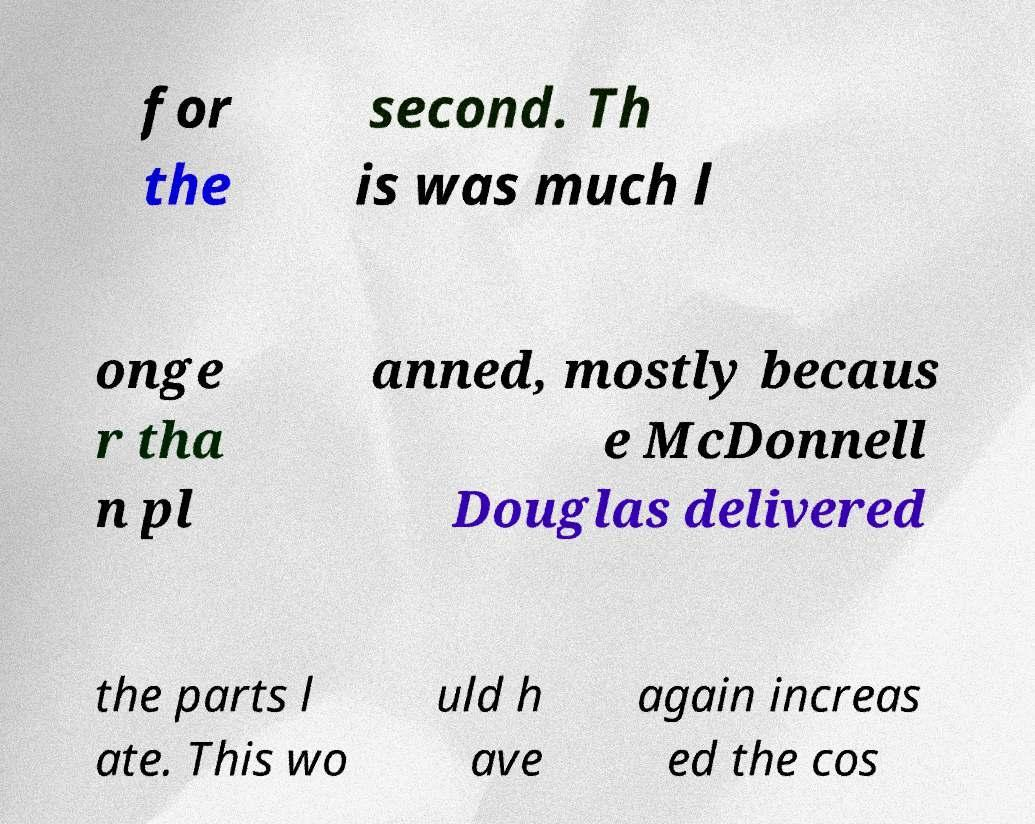For documentation purposes, I need the text within this image transcribed. Could you provide that? for the second. Th is was much l onge r tha n pl anned, mostly becaus e McDonnell Douglas delivered the parts l ate. This wo uld h ave again increas ed the cos 